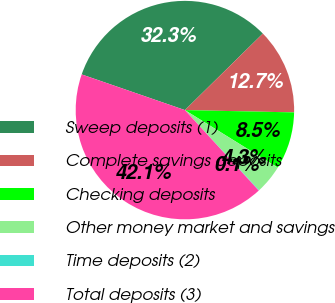Convert chart to OTSL. <chart><loc_0><loc_0><loc_500><loc_500><pie_chart><fcel>Sweep deposits (1)<fcel>Complete savings deposits<fcel>Checking deposits<fcel>Other money market and savings<fcel>Time deposits (2)<fcel>Total deposits (3)<nl><fcel>32.35%<fcel>12.69%<fcel>8.49%<fcel>4.28%<fcel>0.08%<fcel>42.11%<nl></chart> 